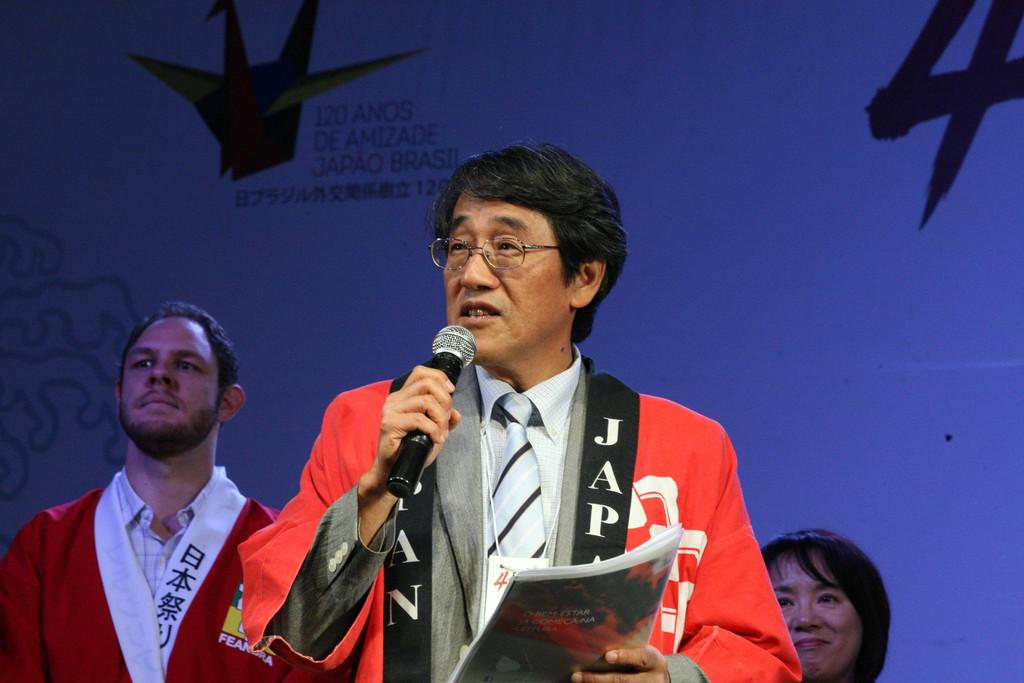<image>
Give a short and clear explanation of the subsequent image. A man talking at 120 Anos De Amizade 